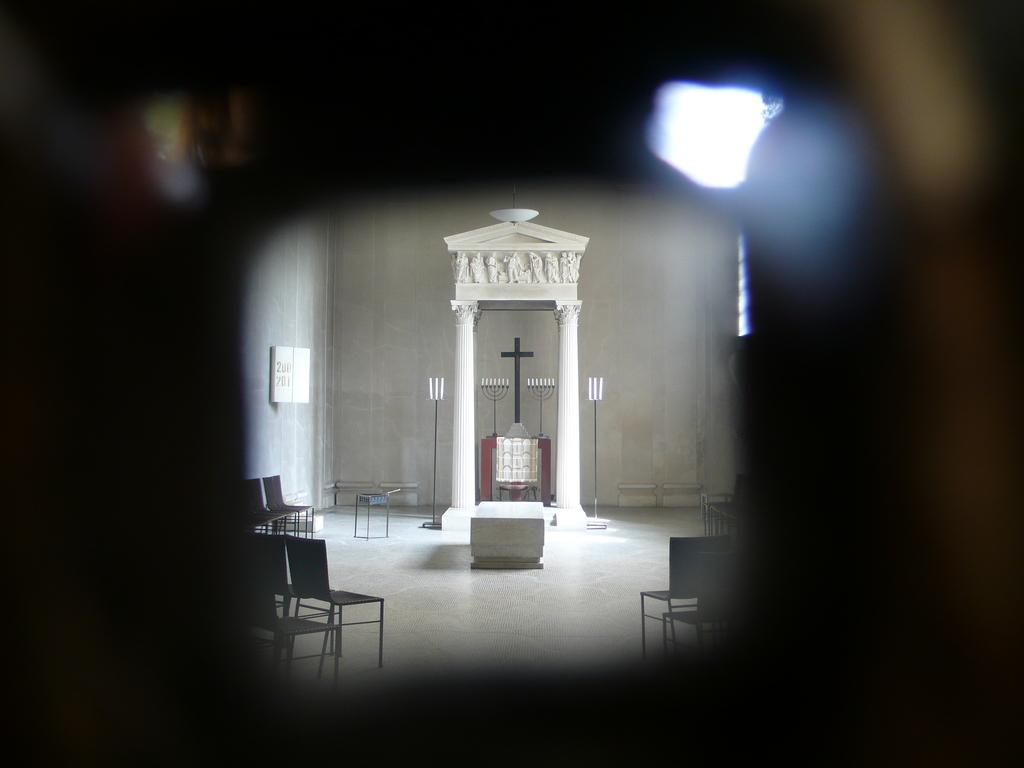What type of structure is present in the image? There is an arch in the image. What can be seen in the background of the image? There are chairs and lights in the background of the image. What type of sidewalk can be seen leading up to the arch in the image? There is no sidewalk present in the image; it only features an arch, chairs, and lights. 